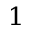<formula> <loc_0><loc_0><loc_500><loc_500>^ { 1 }</formula> 